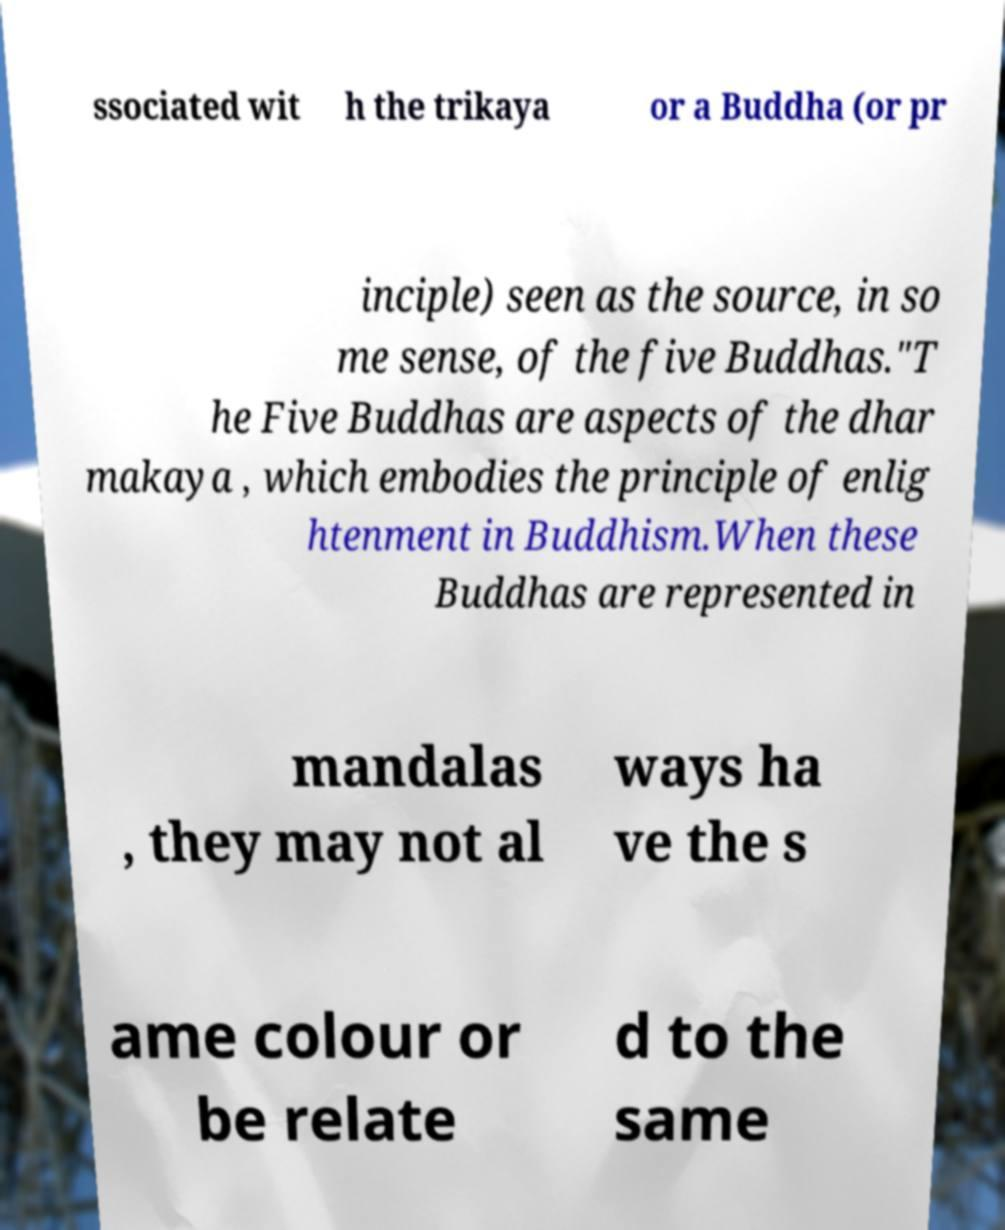What messages or text are displayed in this image? I need them in a readable, typed format. ssociated wit h the trikaya or a Buddha (or pr inciple) seen as the source, in so me sense, of the five Buddhas."T he Five Buddhas are aspects of the dhar makaya , which embodies the principle of enlig htenment in Buddhism.When these Buddhas are represented in mandalas , they may not al ways ha ve the s ame colour or be relate d to the same 